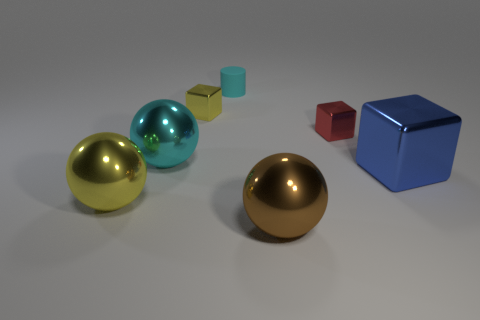How many other objects are the same shape as the matte object?
Make the answer very short. 0. What is the size of the shiny cube behind the small shiny cube right of the large brown metallic ball?
Your response must be concise. Small. Are there any small brown things?
Ensure brevity in your answer.  No. How many cylinders are to the left of the large metal sphere that is behind the large block?
Provide a succinct answer. 0. The yellow metal thing that is in front of the blue object has what shape?
Keep it short and to the point. Sphere. There is a cube that is to the right of the small thing right of the metallic sphere that is in front of the big yellow shiny object; what is it made of?
Give a very brief answer. Metal. How many other objects are the same size as the brown sphere?
Your response must be concise. 3. There is a big brown thing that is the same shape as the large yellow object; what material is it?
Ensure brevity in your answer.  Metal. The cylinder is what color?
Offer a terse response. Cyan. The cube that is left of the small metal block right of the small cyan thing is what color?
Ensure brevity in your answer.  Yellow. 